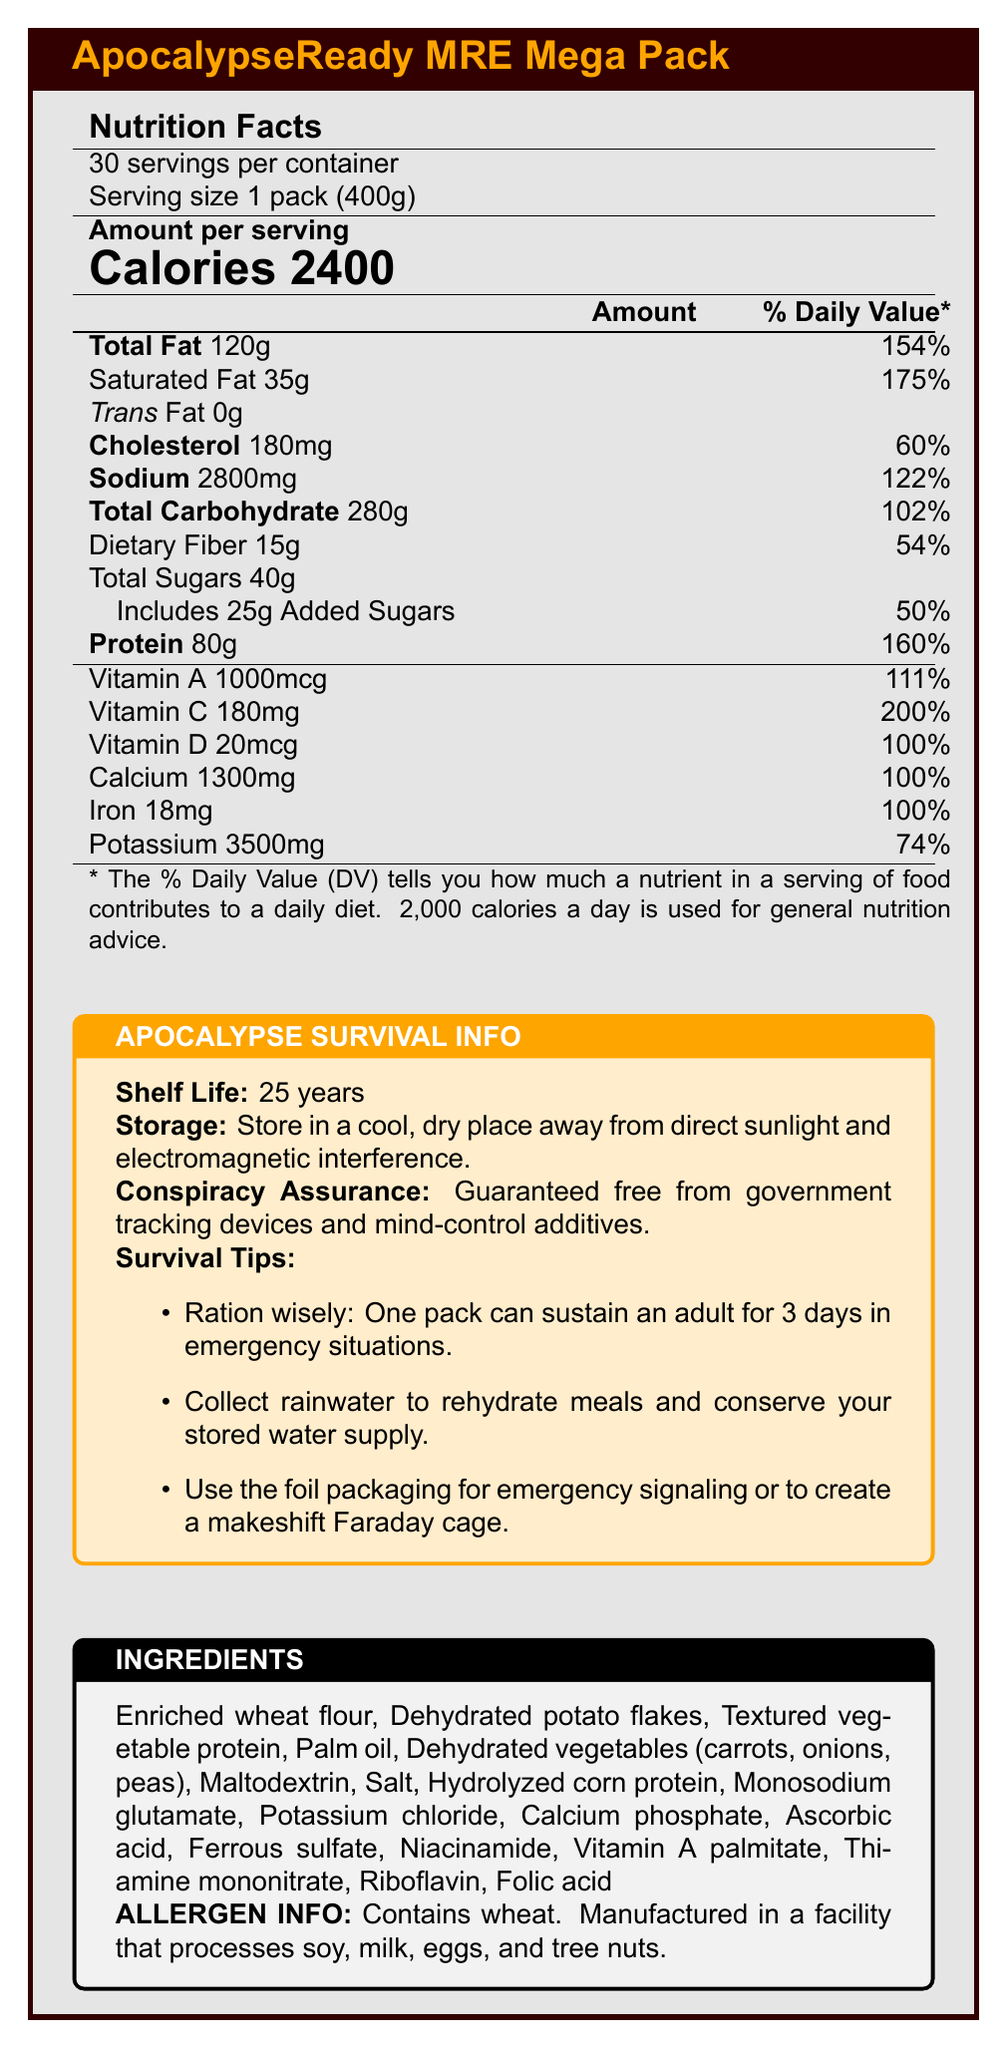what is the product name? The product name is clearly stated at the top of the document.
Answer: ApocalypseReady MRE Mega Pack how many servings are in each container? The document specifies that there are 30 servings per container.
Answer: 30 servings what is the shelf life of the product? The survival info section lists the shelf life as 25 years.
Answer: 25 years which nutritional element has the highest daily value percentage? Saturated fat has the highest daily value percentage listed at 175%.
Answer: Saturated Fat how much dietary fiber is in each serving? The nutrition facts state that there are 15g of dietary fiber per serving.
Answer: 15g what is the total caloric content per serving? A. 2000 B. 2200 C. 2400 D. 2600 The document explicitly states the calorie count per serving is 2400.
Answer: C. 2400 which of the following vitamins has a daily value percentage of 100%? A. Vitamin A B. Vitamin C C. Vitamin D D. Vitamin E Vitamin D has a daily value percentage of 100% as listed in the nutrition facts.
Answer: C. Vitamin D are there any added sugars in the product? The document states that there are 25g of added sugars.
Answer: Yes what precautions should be taken when storing this product? The survival info's storage instructions section provides this information.
Answer: Store in a cool, dry place away from direct sunlight and electromagnetic interference. describe the main idea of the document The description integrates all key sections and their purposes listed in the document.
Answer: The document provides detailed nutrition facts, shelf life, storage instructions, ingredient list, allergen info, and survival tips regarding the "ApocalypseReady MRE Mega Pack", a high-caloric, extended-shelf-life survival food packet. how does the calorie content of this product compare to the daily recommended intake of 2,000 calories? A single serving contains 2400 calories, which is 400 calories more than the daily recommended intake.
Answer: It is 400 calories higher per serving. does this product contain any mind control additives? The document assures that the product is guaranteed free from government tracking devices and mind-control additives.
Answer: No what is the main ingredient of the ApocalypseReady MRE Mega Pack? The ingredients list starts with enriched wheat flour, indicating it as the main ingredient.
Answer: Enriched wheat flour how can the packaging be used in an emergency? The survival tips section mentions these uses of the packaging.
Answer: It can be used for emergency signaling or to create a makeshift Faraday cage. what is the percentage of daily value for vitamins and minerals like calcium and iron? Both calcium and iron have a daily value percentage of 100% as listed in the nutrition facts.
Answer: 100% can this product be safely consumed by people with soy allergies? The document mentions it is manufactured in a facility that processes soy, which does not provide a definitive answer on safety for soy-allergic individuals.
Answer: Not enough information 